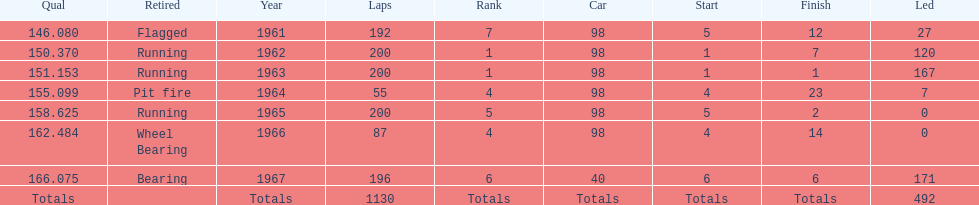How many total laps have been driven in the indy 500? 1130. 